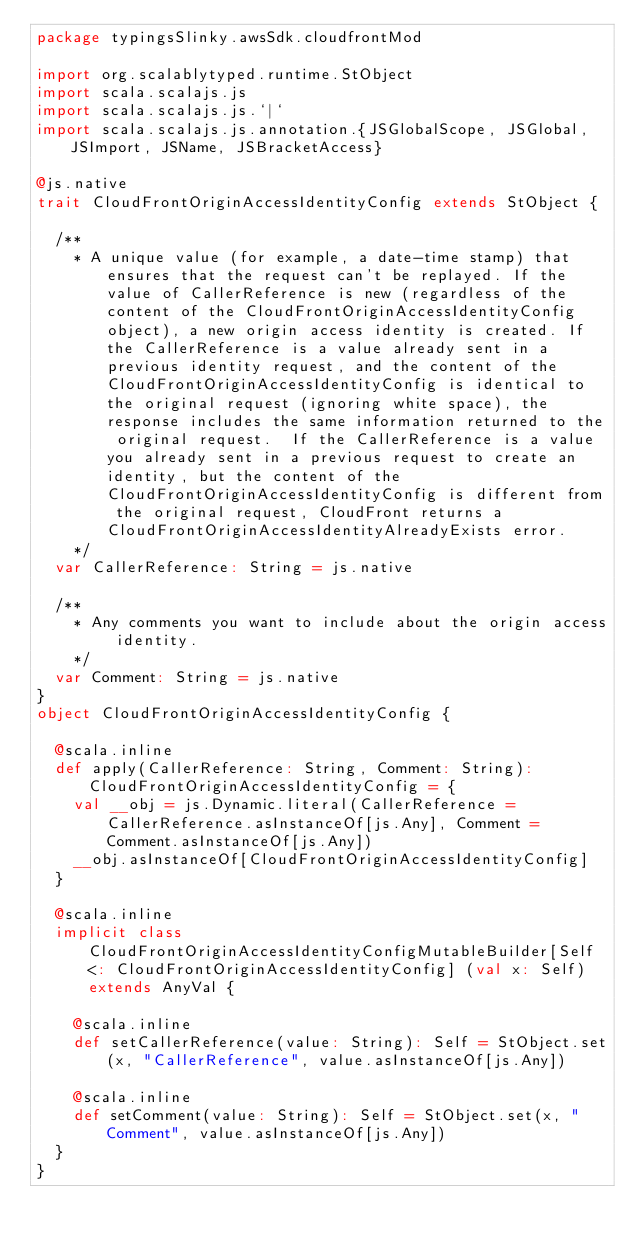Convert code to text. <code><loc_0><loc_0><loc_500><loc_500><_Scala_>package typingsSlinky.awsSdk.cloudfrontMod

import org.scalablytyped.runtime.StObject
import scala.scalajs.js
import scala.scalajs.js.`|`
import scala.scalajs.js.annotation.{JSGlobalScope, JSGlobal, JSImport, JSName, JSBracketAccess}

@js.native
trait CloudFrontOriginAccessIdentityConfig extends StObject {
  
  /**
    * A unique value (for example, a date-time stamp) that ensures that the request can't be replayed. If the value of CallerReference is new (regardless of the content of the CloudFrontOriginAccessIdentityConfig object), a new origin access identity is created. If the CallerReference is a value already sent in a previous identity request, and the content of the CloudFrontOriginAccessIdentityConfig is identical to the original request (ignoring white space), the response includes the same information returned to the original request.  If the CallerReference is a value you already sent in a previous request to create an identity, but the content of the CloudFrontOriginAccessIdentityConfig is different from the original request, CloudFront returns a CloudFrontOriginAccessIdentityAlreadyExists error. 
    */
  var CallerReference: String = js.native
  
  /**
    * Any comments you want to include about the origin access identity. 
    */
  var Comment: String = js.native
}
object CloudFrontOriginAccessIdentityConfig {
  
  @scala.inline
  def apply(CallerReference: String, Comment: String): CloudFrontOriginAccessIdentityConfig = {
    val __obj = js.Dynamic.literal(CallerReference = CallerReference.asInstanceOf[js.Any], Comment = Comment.asInstanceOf[js.Any])
    __obj.asInstanceOf[CloudFrontOriginAccessIdentityConfig]
  }
  
  @scala.inline
  implicit class CloudFrontOriginAccessIdentityConfigMutableBuilder[Self <: CloudFrontOriginAccessIdentityConfig] (val x: Self) extends AnyVal {
    
    @scala.inline
    def setCallerReference(value: String): Self = StObject.set(x, "CallerReference", value.asInstanceOf[js.Any])
    
    @scala.inline
    def setComment(value: String): Self = StObject.set(x, "Comment", value.asInstanceOf[js.Any])
  }
}
</code> 